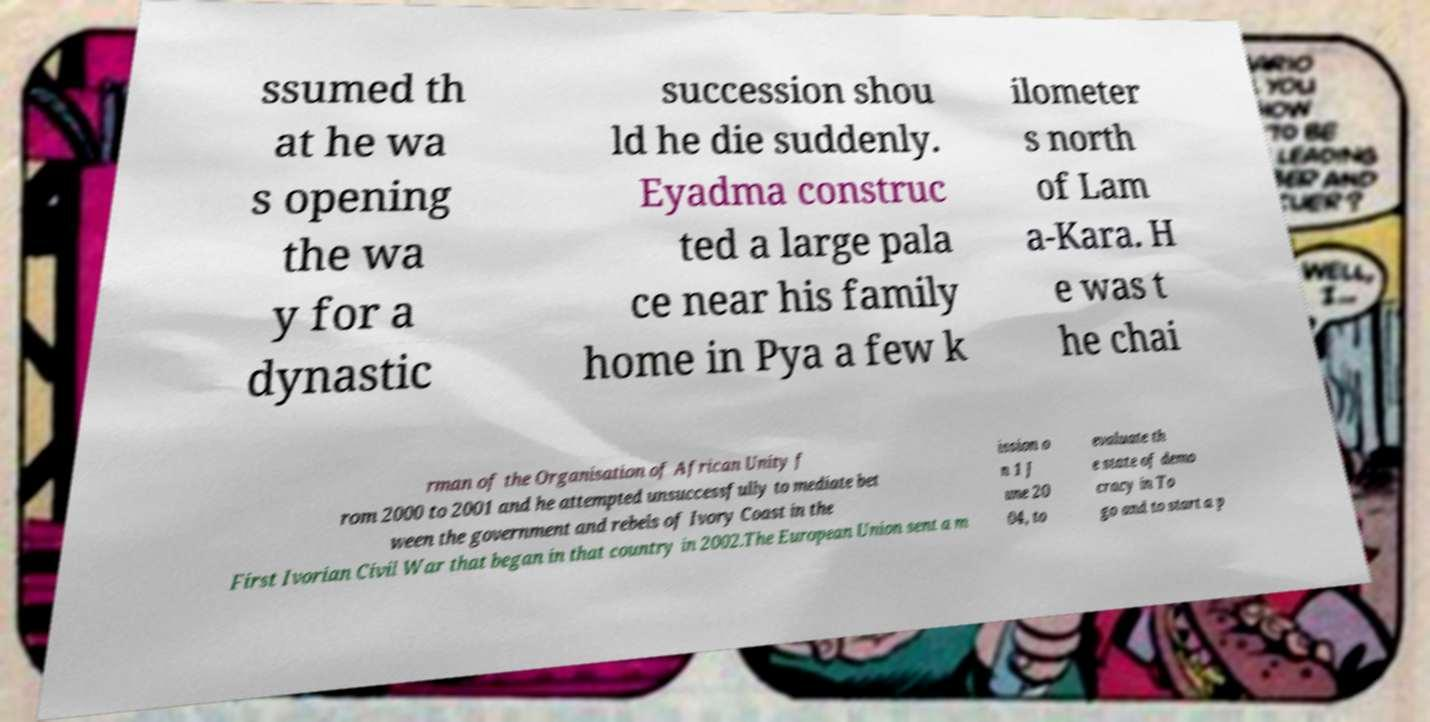Please read and relay the text visible in this image. What does it say? ssumed th at he wa s opening the wa y for a dynastic succession shou ld he die suddenly. Eyadma construc ted a large pala ce near his family home in Pya a few k ilometer s north of Lam a-Kara. H e was t he chai rman of the Organisation of African Unity f rom 2000 to 2001 and he attempted unsuccessfully to mediate bet ween the government and rebels of Ivory Coast in the First Ivorian Civil War that began in that country in 2002.The European Union sent a m ission o n 1 J une 20 04, to evaluate th e state of demo cracy in To go and to start a p 